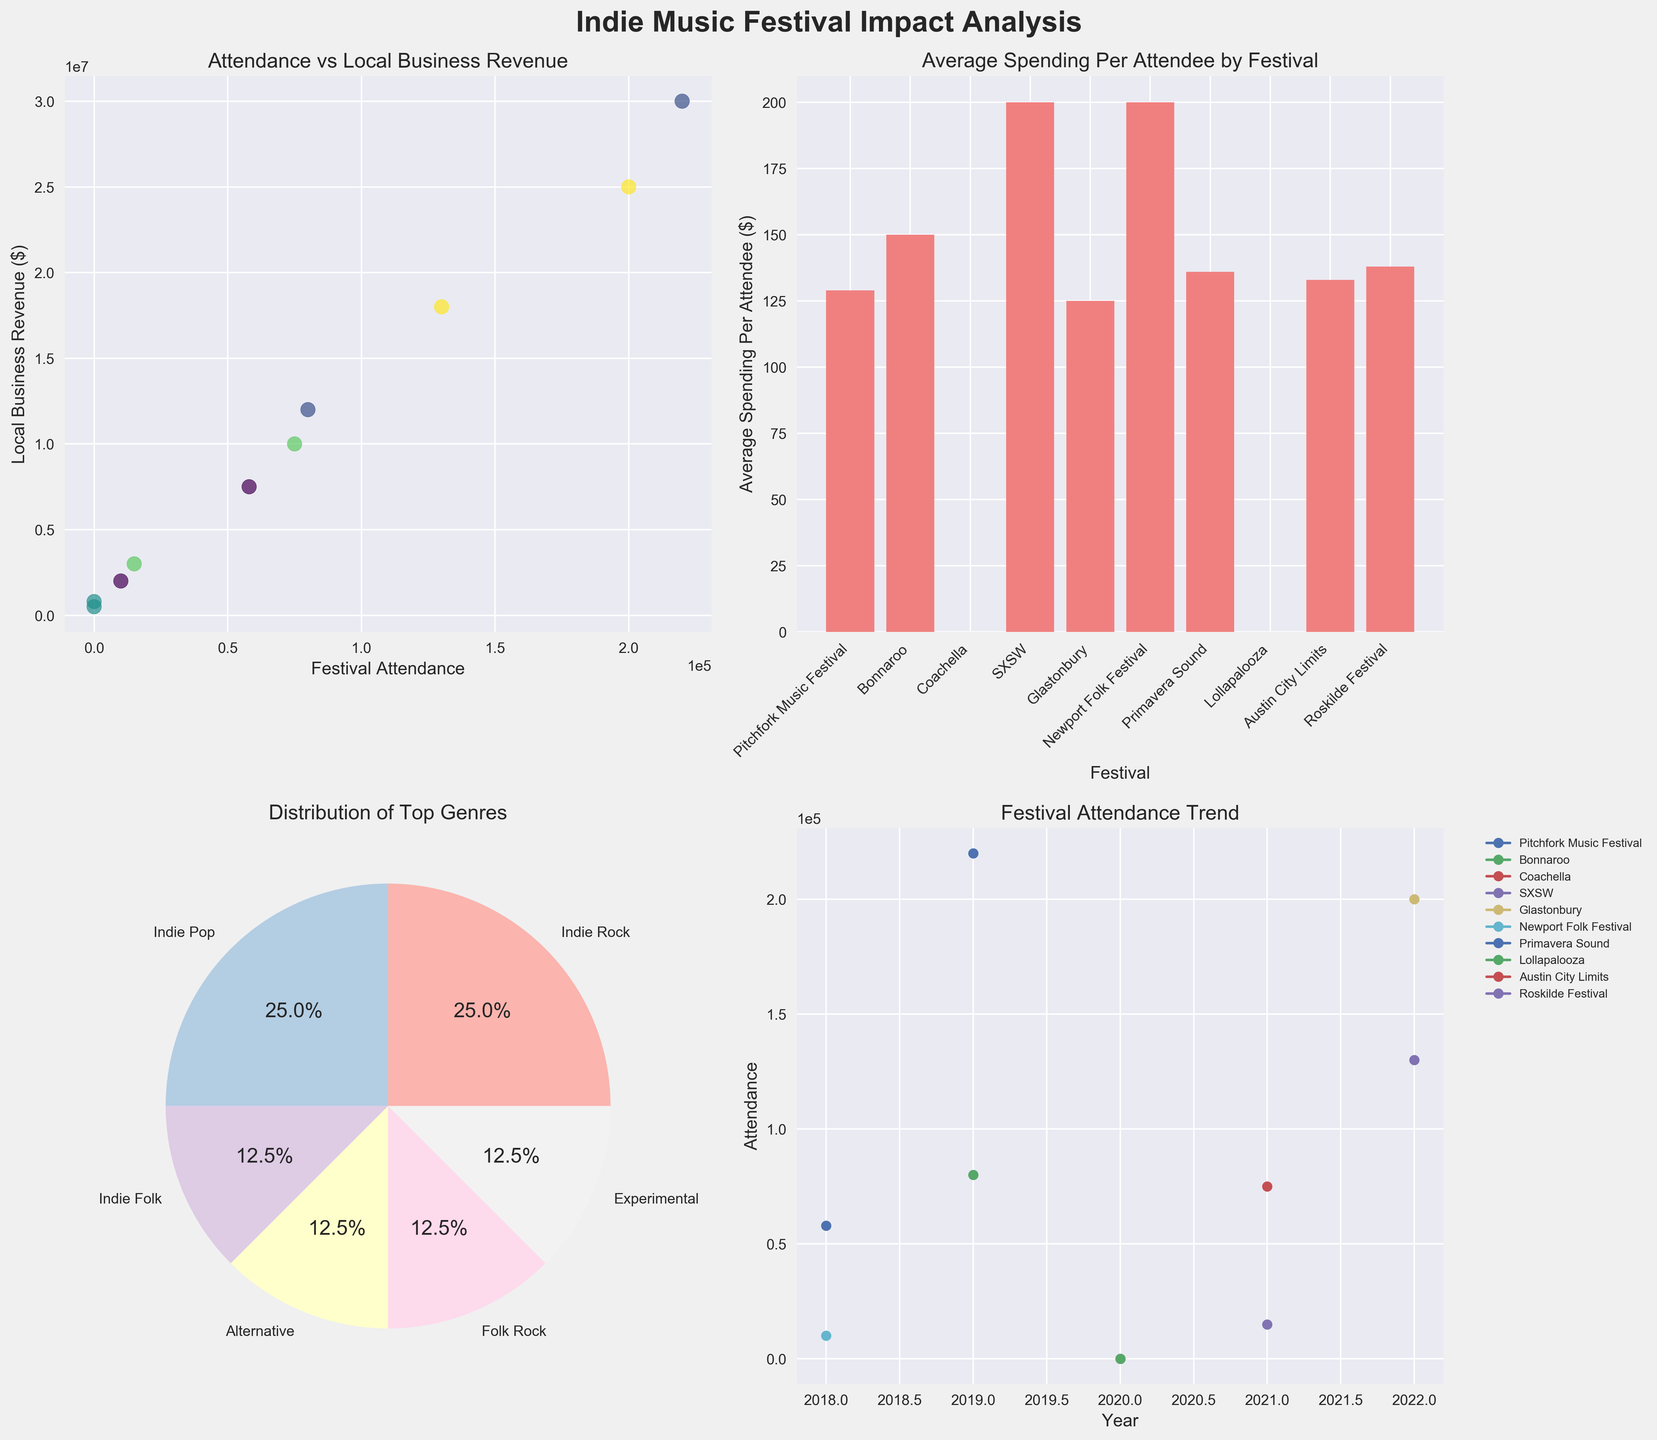Scatter Plot: Attendance vs Local Business Revenue - What is the title of the scatter plot? The title of the scatter plot is labeled at the top of the relevant subplot. It's written as "Attendance vs Local Business Revenue".
Answer: Attendance vs Local Business Revenue Bar Plot: Average Spending Per Attendee - Which festival had the highest average spending per attendee? The bar plot shows the average spending per attendee for each festival. Among all the festivals, SXSW has the highest bar indicating it had the highest spending per attendee.
Answer: SXSW Pie Chart: Distribution of Top Genres - What percentage of the festivals feature Indie Pop as the top genre? The pie chart slice corresponding to Indie Pop is labeled with a percentage value of 20%.
Answer: 20% Line Plot: Festival Attendance Trend - How does festival attendance for Austin City Limits change over the years? By observing the line plot lines and markers, the line for Austin City Limits shows an increase in attendance data point in 2021 compared to previous years.
Answer: Increases in 2021 Scatter Plot: Attendance vs Local Business Revenue - Which year had the highest festival attendance? In the scatter plot, the year with the highest y-axis (attendance) value is corresponding to the year 2022.
Answer: 2022 Bar Plot: Average Spending Per Attendee - What is the average spending per attendee at Bonnaroo? From the bar plot, the height of the bar for Bonnaroo aligns with the value of 150 dollars.
Answer: 150 dollars Line Plot: Festival Attendance Trend - Which festival shows attendance only in the year 2022? The line plot shows a single marker for Glastonbury in 2022 indicating it has attendance data only for that year.
Answer: Glastonbury Scatter Plot: Attendance vs Local Business Revenue - Is there a positive correlation between festival attendance and local business revenue? The scatter plot shows a trend where higher attendance generally corresponds to higher local business revenue, indicating a positive correlation.
Answer: Yes Pie Chart: Distribution of Top Genres - Which genre is most commonly the top genre among the festivals? The pie chart shows that Indie Rock has the largest slice representing the highest percentage.
Answer: Indie Rock Scatter Plot: Attendance vs Local Business Revenue - Calculate the total local business revenue for all festivals shown. Summing up all relevant y-axis values from the scatter plot: 7,500,000 (2018) + 12,000,000 (2019) + 500,000 (2020) + 3,000,000 (2021) + 25,000,000 (2022) + 2,000,000 (2018) + 30,000,000 (2019) + 800,000 (2020) + 10,000,000 (2021) + 18,000,000 (2022) = 108,800,000
Answer: 108,800,000 